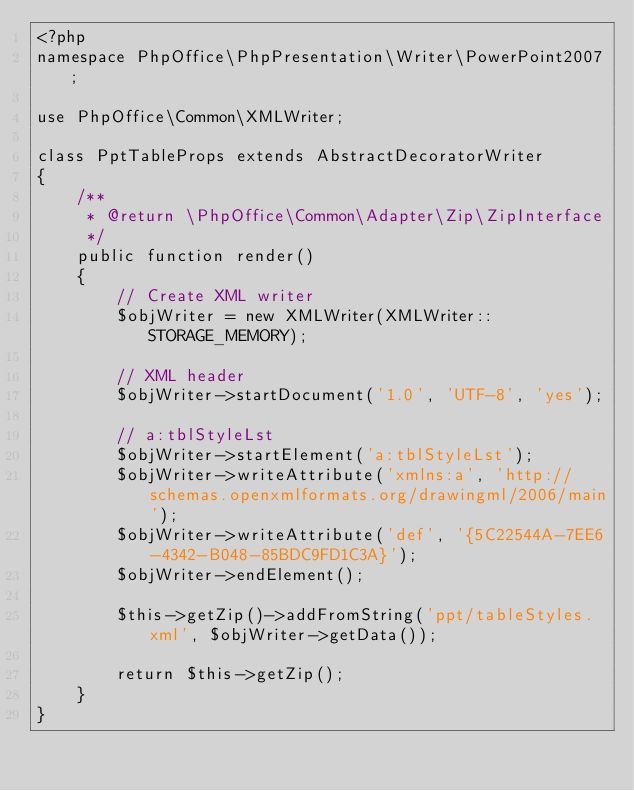Convert code to text. <code><loc_0><loc_0><loc_500><loc_500><_PHP_><?php
namespace PhpOffice\PhpPresentation\Writer\PowerPoint2007;

use PhpOffice\Common\XMLWriter;

class PptTableProps extends AbstractDecoratorWriter
{
    /**
     * @return \PhpOffice\Common\Adapter\Zip\ZipInterface
     */
    public function render()
    {
        // Create XML writer
        $objWriter = new XMLWriter(XMLWriter::STORAGE_MEMORY);

        // XML header
        $objWriter->startDocument('1.0', 'UTF-8', 'yes');

        // a:tblStyleLst
        $objWriter->startElement('a:tblStyleLst');
        $objWriter->writeAttribute('xmlns:a', 'http://schemas.openxmlformats.org/drawingml/2006/main');
        $objWriter->writeAttribute('def', '{5C22544A-7EE6-4342-B048-85BDC9FD1C3A}');
        $objWriter->endElement();

        $this->getZip()->addFromString('ppt/tableStyles.xml', $objWriter->getData());

        return $this->getZip();
    }
}
</code> 